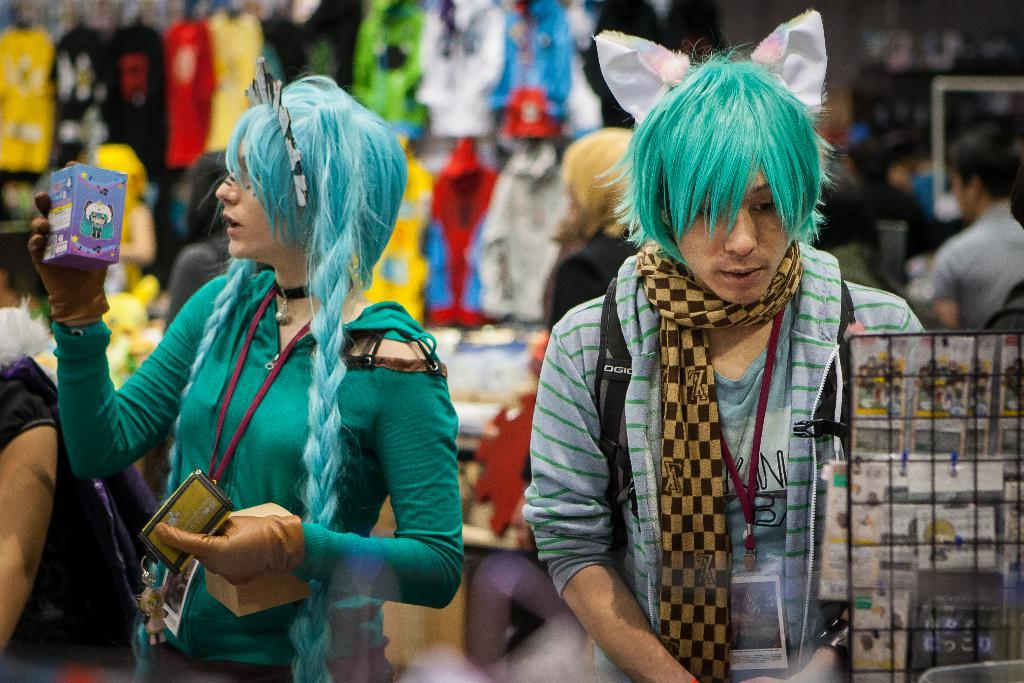How many people are in the image? There are people in the image, but the exact number is not specified. What are the people holding in the image? The people are holding boxes in the image. What type of oil is being used to make the decision in the image? There is no mention of oil or decision-making in the image; it only shows people holding boxes. 